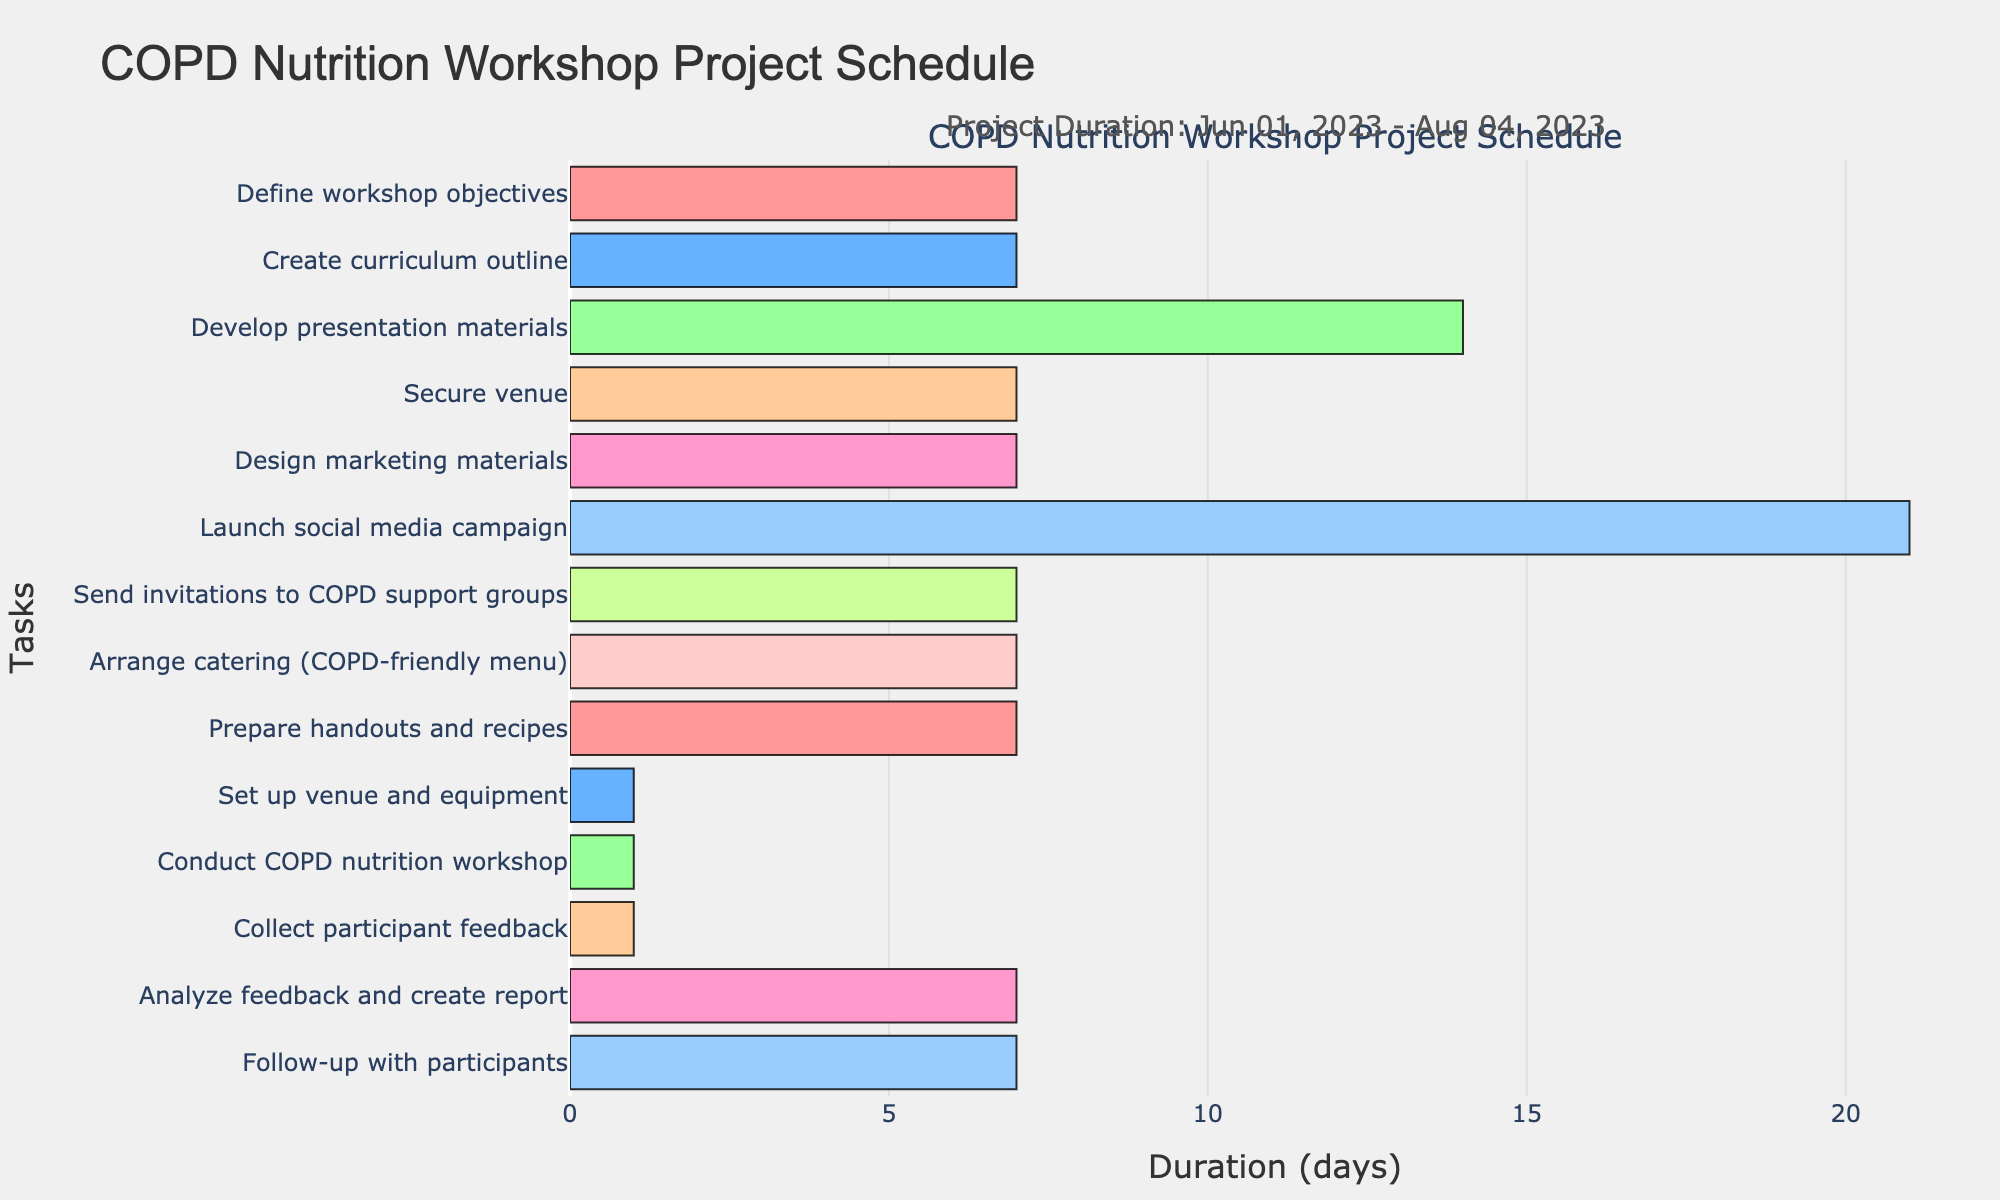What is the title of the Gantt chart? The title is prominently displayed at the top of the chart, indicating the purpose or subject of the visualization.
Answer: COPD Nutrition Workshop Project Schedule What is the duration of the "Create curriculum outline" task? By looking at the task on the vertical axis and tracking its accompanying bar on the horizontal axis, you can see the duration from start to end dates. It spans from June 8, 2023, to June 14, 2023.
Answer: 7 days Which task has the longest duration? By comparing the length of the bars on the horizontal axis representing the duration of each task, the longest bar indicates the task with the longest duration. The "Launch social media campaign" spans from June 29, 2023, to July 19, 2023, which is 21 days.
Answer: Launch social media campaign Which two tasks occur simultaneously between June 29, 2023, and July 5, 2023? By looking at the bars that overlap in the given date range on the horizontal axis, you can identify that "Launch social media campaign" and "Send invitations to COPD support groups" both start on June 29, 2023.
Answer: Launch social media campaign and Send invitations to COPD support groups What is the combined duration of "Develop presentation materials" and "Secure venue"? The duration of "Develop presentation materials" is 14 days (June 15, 2023, to June 28, 2023) and the duration of "Secure venue" is 7 days (June 15, 2023, to June 21, 2023). Adding these together gives: 14 + 7 = 21 days.
Answer: 21 days When does the "Arrange catering" task begin and end? By locating the task on the vertical axis and following the bar across the horizontal axis, the start date is July 6, 2023, and the end date is July 12, 2023.
Answer: July 6, 2023, and July 12, 2023 How many tasks are completed before July 1, 2023? By identifying the tasks ending before July 1, 2023, you can count them: "Define workshop objectives," "Create curriculum outline," "Develop presentation materials," "Secure venue," and "Design marketing materials" all end before this date.
Answer: 5 tasks Which task directly follows "Set up venue and equipment" in terms of the timeline? By identifying the sequence of tasks on the vertical axis and noting their start and end dates, "Conduct COPD nutrition workshop" follows "Set up venue and equipment," both occurring on July 21, 2023.
Answer: Conduct COPD nutrition workshop What is the last task in the project schedule? By looking at the order of tasks and their respective end dates, the "Follow-up with participants" task ends on August 4, 2023, making it the final task scheduled.
Answer: Follow-up with participants 